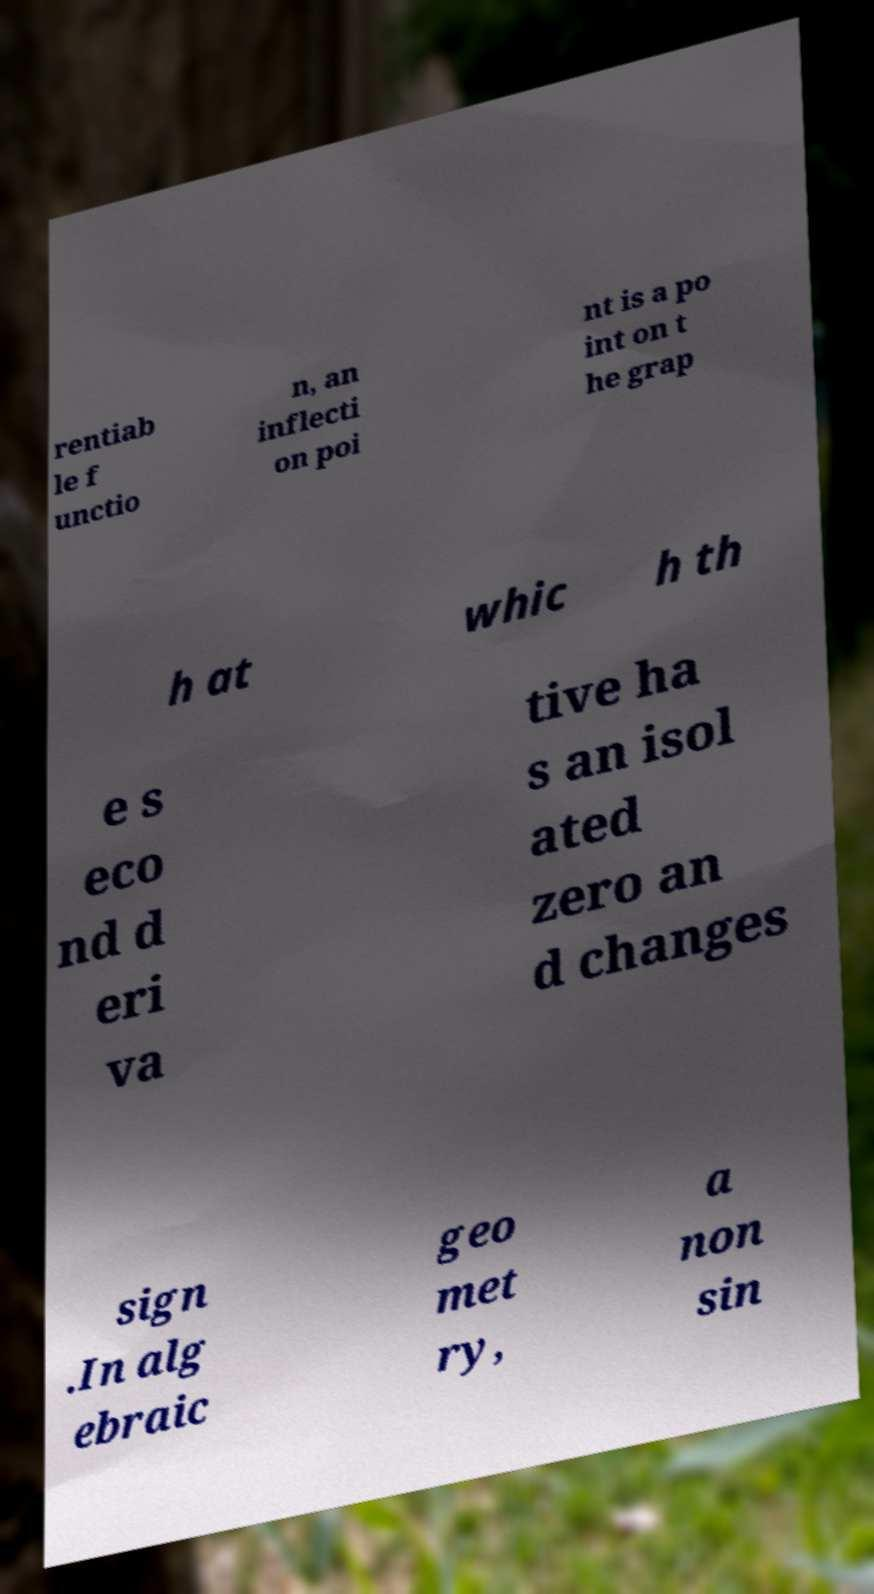For documentation purposes, I need the text within this image transcribed. Could you provide that? rentiab le f unctio n, an inflecti on poi nt is a po int on t he grap h at whic h th e s eco nd d eri va tive ha s an isol ated zero an d changes sign .In alg ebraic geo met ry, a non sin 